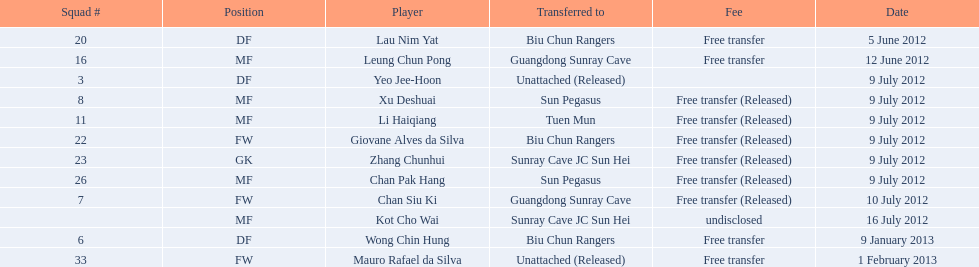Who are the players listed? Lau Nim Yat, Leung Chun Pong, Yeo Jee-Hoon, Xu Deshuai, Li Haiqiang, Giovane Alves da Silva, Zhang Chunhui, Chan Pak Hang, Chan Siu Ki, Kot Cho Wai, Wong Chin Hung, Mauro Rafael da Silva. When were they transferred to biu chun rangers? 5 June 2012, 9 July 2012, 9 January 2013. Specifically, what is the transfer date for wong chin hung? 9 January 2013. 